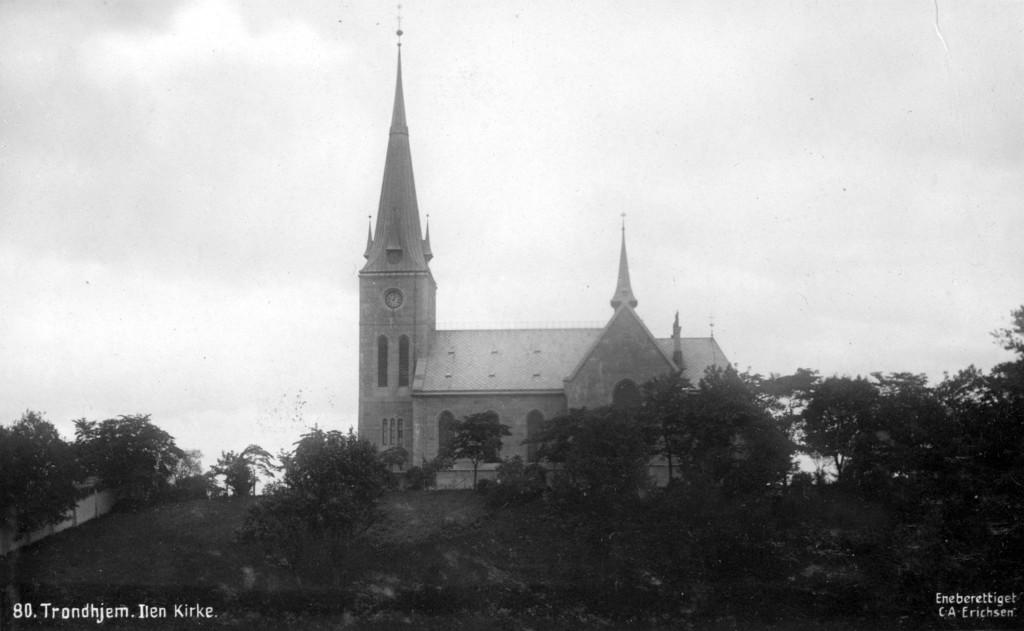What type of natural elements can be seen in the image? There are trees in the image. What structure is located in the middle of the image? There is a building in the middle of the image. What is written or displayed at the bottom of the image? There is text at the bottom of the image. How is the image presented in terms of color? The photography is in black and white. What type of boundary is depicted in the image? There is no boundary depicted in the image; it features trees, a building, and text. What is the wealth status of the person in the image? There is no person present in the image, so their wealth status cannot be determined. 